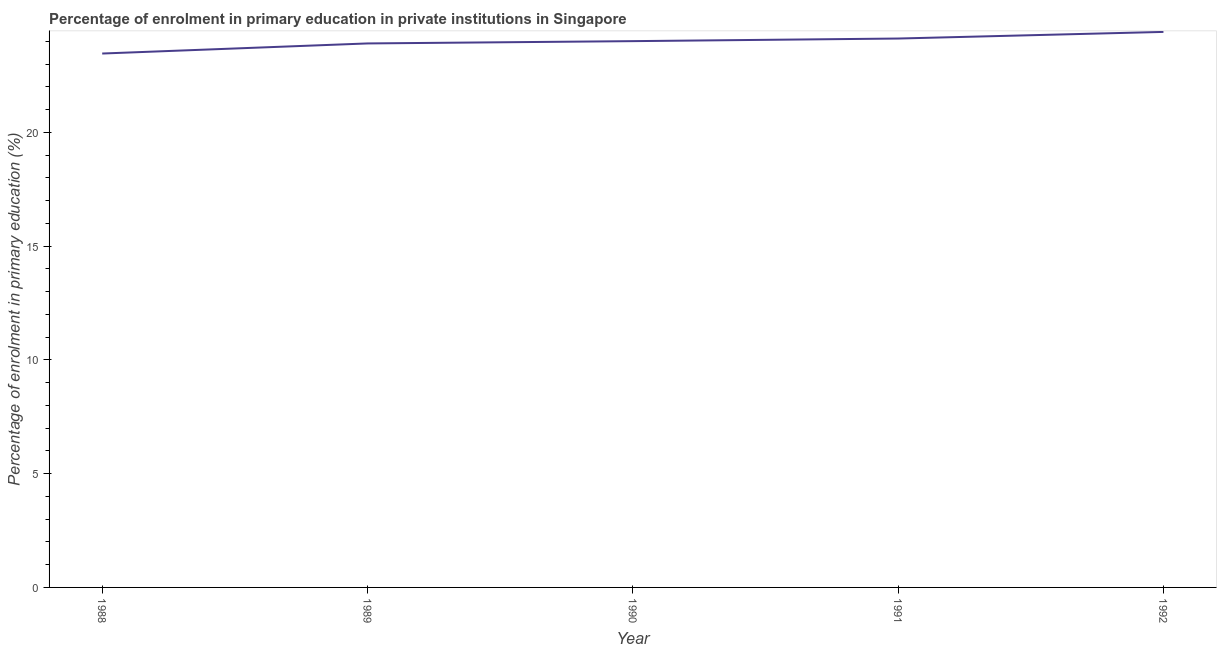What is the enrolment percentage in primary education in 1991?
Provide a short and direct response. 24.13. Across all years, what is the maximum enrolment percentage in primary education?
Give a very brief answer. 24.42. Across all years, what is the minimum enrolment percentage in primary education?
Your answer should be compact. 23.47. In which year was the enrolment percentage in primary education maximum?
Your response must be concise. 1992. In which year was the enrolment percentage in primary education minimum?
Your answer should be very brief. 1988. What is the sum of the enrolment percentage in primary education?
Offer a terse response. 119.93. What is the difference between the enrolment percentage in primary education in 1988 and 1992?
Your answer should be compact. -0.95. What is the average enrolment percentage in primary education per year?
Offer a very short reply. 23.99. What is the median enrolment percentage in primary education?
Provide a short and direct response. 24.01. In how many years, is the enrolment percentage in primary education greater than 6 %?
Your answer should be very brief. 5. What is the ratio of the enrolment percentage in primary education in 1989 to that in 1992?
Give a very brief answer. 0.98. What is the difference between the highest and the second highest enrolment percentage in primary education?
Provide a succinct answer. 0.29. What is the difference between the highest and the lowest enrolment percentage in primary education?
Give a very brief answer. 0.95. In how many years, is the enrolment percentage in primary education greater than the average enrolment percentage in primary education taken over all years?
Your answer should be very brief. 3. Does the enrolment percentage in primary education monotonically increase over the years?
Give a very brief answer. Yes. How many years are there in the graph?
Provide a succinct answer. 5. What is the difference between two consecutive major ticks on the Y-axis?
Offer a very short reply. 5. Are the values on the major ticks of Y-axis written in scientific E-notation?
Keep it short and to the point. No. Does the graph contain any zero values?
Ensure brevity in your answer.  No. What is the title of the graph?
Make the answer very short. Percentage of enrolment in primary education in private institutions in Singapore. What is the label or title of the X-axis?
Offer a terse response. Year. What is the label or title of the Y-axis?
Keep it short and to the point. Percentage of enrolment in primary education (%). What is the Percentage of enrolment in primary education (%) of 1988?
Your answer should be compact. 23.47. What is the Percentage of enrolment in primary education (%) of 1989?
Your answer should be very brief. 23.91. What is the Percentage of enrolment in primary education (%) in 1990?
Provide a succinct answer. 24.01. What is the Percentage of enrolment in primary education (%) in 1991?
Offer a very short reply. 24.13. What is the Percentage of enrolment in primary education (%) in 1992?
Give a very brief answer. 24.42. What is the difference between the Percentage of enrolment in primary education (%) in 1988 and 1989?
Keep it short and to the point. -0.44. What is the difference between the Percentage of enrolment in primary education (%) in 1988 and 1990?
Provide a short and direct response. -0.54. What is the difference between the Percentage of enrolment in primary education (%) in 1988 and 1991?
Your response must be concise. -0.66. What is the difference between the Percentage of enrolment in primary education (%) in 1988 and 1992?
Your response must be concise. -0.95. What is the difference between the Percentage of enrolment in primary education (%) in 1989 and 1990?
Your response must be concise. -0.1. What is the difference between the Percentage of enrolment in primary education (%) in 1989 and 1991?
Make the answer very short. -0.22. What is the difference between the Percentage of enrolment in primary education (%) in 1989 and 1992?
Provide a short and direct response. -0.51. What is the difference between the Percentage of enrolment in primary education (%) in 1990 and 1991?
Give a very brief answer. -0.11. What is the difference between the Percentage of enrolment in primary education (%) in 1990 and 1992?
Ensure brevity in your answer.  -0.41. What is the difference between the Percentage of enrolment in primary education (%) in 1991 and 1992?
Your answer should be very brief. -0.29. What is the ratio of the Percentage of enrolment in primary education (%) in 1988 to that in 1989?
Give a very brief answer. 0.98. What is the ratio of the Percentage of enrolment in primary education (%) in 1988 to that in 1990?
Provide a short and direct response. 0.98. What is the ratio of the Percentage of enrolment in primary education (%) in 1988 to that in 1991?
Offer a very short reply. 0.97. What is the ratio of the Percentage of enrolment in primary education (%) in 1988 to that in 1992?
Provide a short and direct response. 0.96. What is the ratio of the Percentage of enrolment in primary education (%) in 1989 to that in 1991?
Offer a very short reply. 0.99. What is the ratio of the Percentage of enrolment in primary education (%) in 1990 to that in 1991?
Your response must be concise. 0.99. What is the ratio of the Percentage of enrolment in primary education (%) in 1990 to that in 1992?
Offer a very short reply. 0.98. 